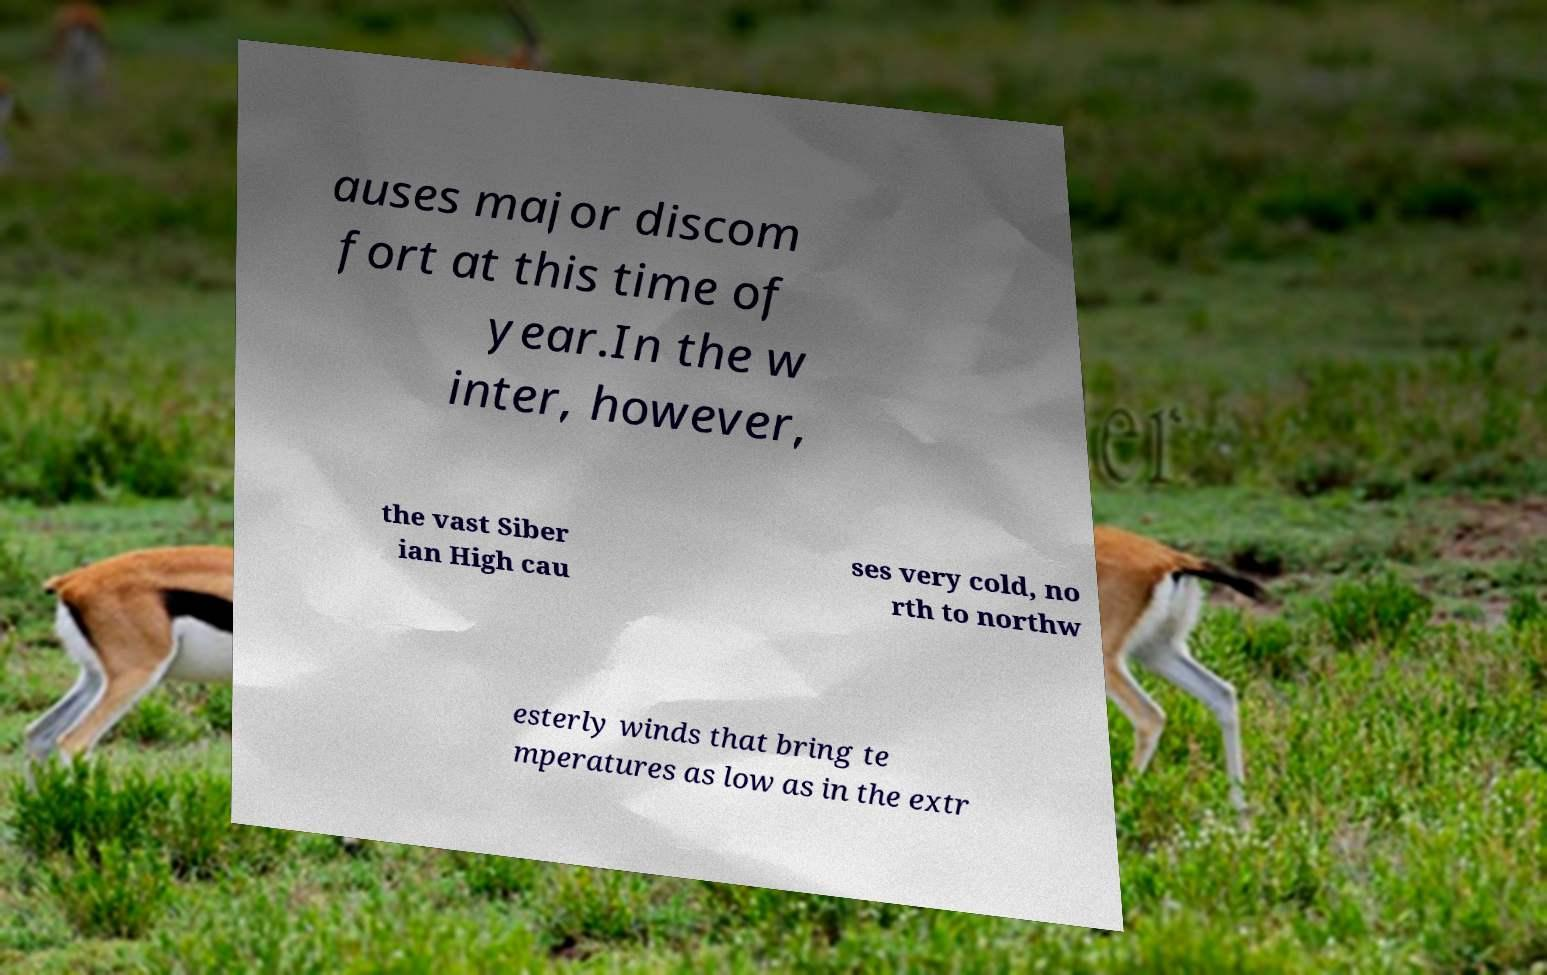Could you extract and type out the text from this image? auses major discom fort at this time of year.In the w inter, however, the vast Siber ian High cau ses very cold, no rth to northw esterly winds that bring te mperatures as low as in the extr 